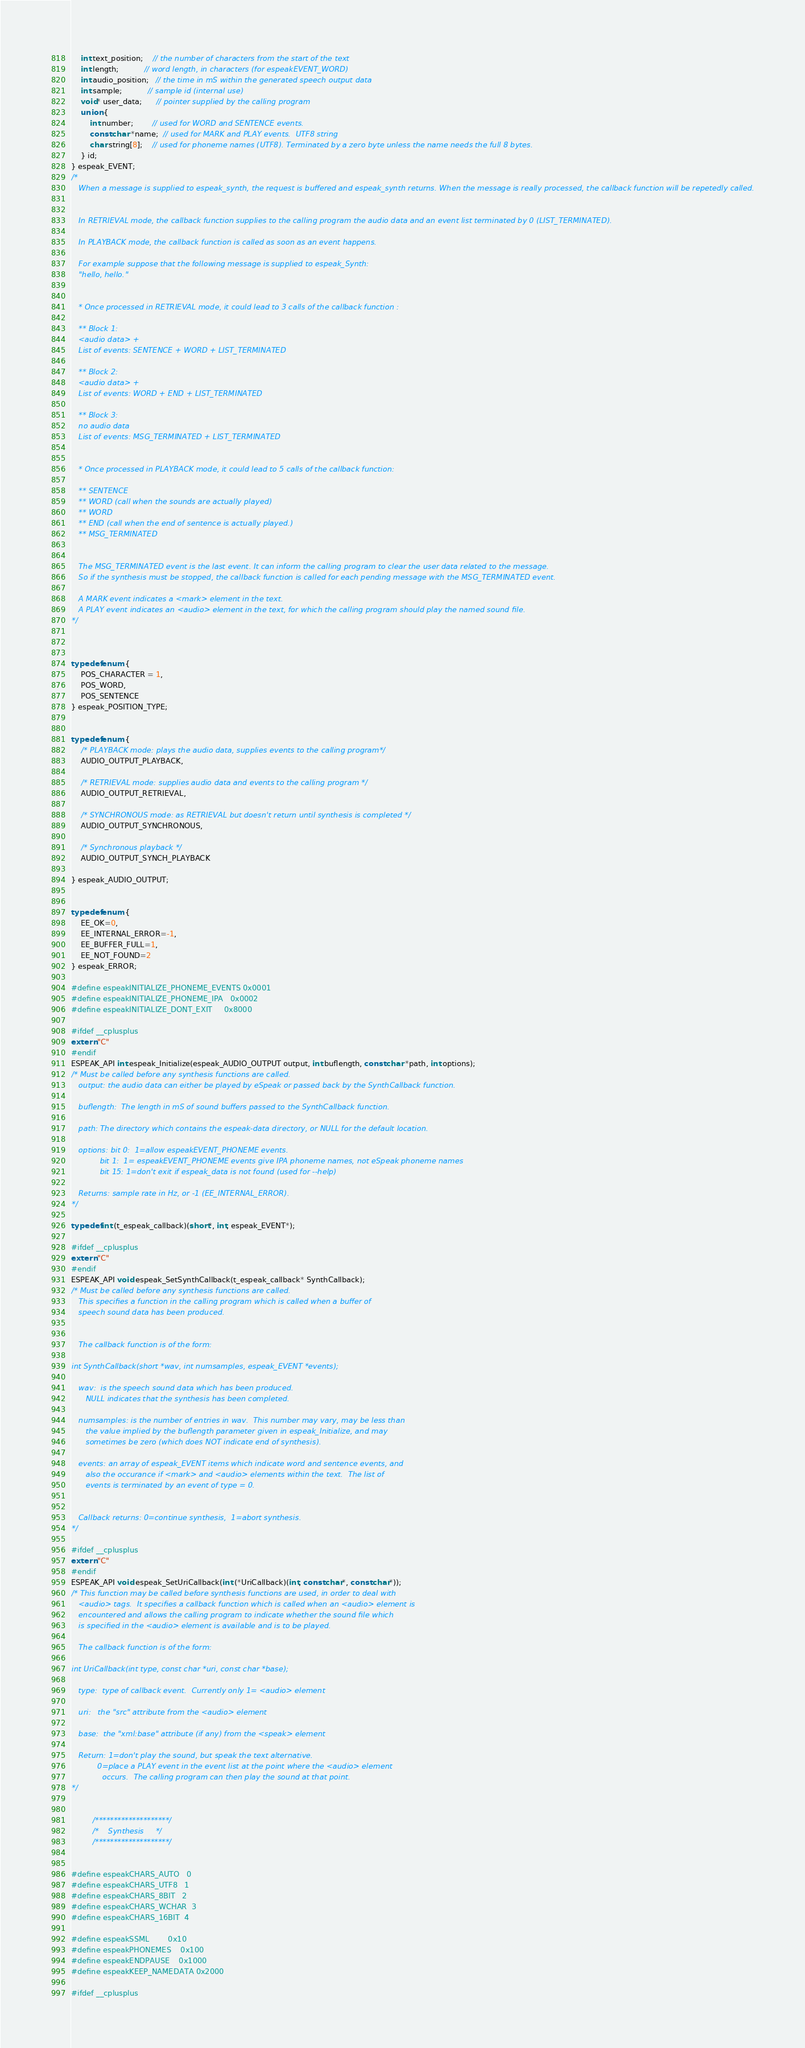Convert code to text. <code><loc_0><loc_0><loc_500><loc_500><_C_>	int text_position;    // the number of characters from the start of the text
	int length;           // word length, in characters (for espeakEVENT_WORD)
	int audio_position;   // the time in mS within the generated speech output data
	int sample;           // sample id (internal use)
	void* user_data;      // pointer supplied by the calling program
	union {
		int number;        // used for WORD and SENTENCE events.
		const char *name;  // used for MARK and PLAY events.  UTF8 string
		char string[8];    // used for phoneme names (UTF8). Terminated by a zero byte unless the name needs the full 8 bytes.
	} id;
} espeak_EVENT;
/* 
   When a message is supplied to espeak_synth, the request is buffered and espeak_synth returns. When the message is really processed, the callback function will be repetedly called.


   In RETRIEVAL mode, the callback function supplies to the calling program the audio data and an event list terminated by 0 (LIST_TERMINATED).

   In PLAYBACK mode, the callback function is called as soon as an event happens.

   For example suppose that the following message is supplied to espeak_Synth: 
   "hello, hello."


   * Once processed in RETRIEVAL mode, it could lead to 3 calls of the callback function :

   ** Block 1:
   <audio data> + 
   List of events: SENTENCE + WORD + LIST_TERMINATED
 
   ** Block 2:
   <audio data> +
   List of events: WORD + END + LIST_TERMINATED

   ** Block 3:
   no audio data
   List of events: MSG_TERMINATED + LIST_TERMINATED


   * Once processed in PLAYBACK mode, it could lead to 5 calls of the callback function:

   ** SENTENCE
   ** WORD (call when the sounds are actually played)
   ** WORD
   ** END (call when the end of sentence is actually played.)
   ** MSG_TERMINATED


   The MSG_TERMINATED event is the last event. It can inform the calling program to clear the user data related to the message.
   So if the synthesis must be stopped, the callback function is called for each pending message with the MSG_TERMINATED event.

   A MARK event indicates a <mark> element in the text.
   A PLAY event indicates an <audio> element in the text, for which the calling program should play the named sound file.
*/



typedef enum {
	POS_CHARACTER = 1,
	POS_WORD,
	POS_SENTENCE
} espeak_POSITION_TYPE;


typedef enum {
	/* PLAYBACK mode: plays the audio data, supplies events to the calling program*/
	AUDIO_OUTPUT_PLAYBACK, 

	/* RETRIEVAL mode: supplies audio data and events to the calling program */
	AUDIO_OUTPUT_RETRIEVAL,
 
	/* SYNCHRONOUS mode: as RETRIEVAL but doesn't return until synthesis is completed */
	AUDIO_OUTPUT_SYNCHRONOUS,

	/* Synchronous playback */
	AUDIO_OUTPUT_SYNCH_PLAYBACK

} espeak_AUDIO_OUTPUT;


typedef enum {
	EE_OK=0,
	EE_INTERNAL_ERROR=-1,
	EE_BUFFER_FULL=1,
	EE_NOT_FOUND=2
} espeak_ERROR;

#define espeakINITIALIZE_PHONEME_EVENTS 0x0001
#define espeakINITIALIZE_PHONEME_IPA   0x0002
#define espeakINITIALIZE_DONT_EXIT     0x8000

#ifdef __cplusplus
extern "C"
#endif
ESPEAK_API int espeak_Initialize(espeak_AUDIO_OUTPUT output, int buflength, const char *path, int options);
/* Must be called before any synthesis functions are called.
   output: the audio data can either be played by eSpeak or passed back by the SynthCallback function.

   buflength:  The length in mS of sound buffers passed to the SynthCallback function.

   path: The directory which contains the espeak-data directory, or NULL for the default location.

   options: bit 0:  1=allow espeakEVENT_PHONEME events.
            bit 1:  1= espeakEVENT_PHONEME events give IPA phoneme names, not eSpeak phoneme names
            bit 15: 1=don't exit if espeak_data is not found (used for --help)

   Returns: sample rate in Hz, or -1 (EE_INTERNAL_ERROR).
*/

typedef int (t_espeak_callback)(short*, int, espeak_EVENT*);

#ifdef __cplusplus
extern "C"
#endif
ESPEAK_API void espeak_SetSynthCallback(t_espeak_callback* SynthCallback);
/* Must be called before any synthesis functions are called.
   This specifies a function in the calling program which is called when a buffer of
   speech sound data has been produced. 


   The callback function is of the form:

int SynthCallback(short *wav, int numsamples, espeak_EVENT *events);

   wav:  is the speech sound data which has been produced.
      NULL indicates that the synthesis has been completed.

   numsamples: is the number of entries in wav.  This number may vary, may be less than
      the value implied by the buflength parameter given in espeak_Initialize, and may
      sometimes be zero (which does NOT indicate end of synthesis).

   events: an array of espeak_EVENT items which indicate word and sentence events, and
      also the occurance if <mark> and <audio> elements within the text.  The list of
      events is terminated by an event of type = 0.


   Callback returns: 0=continue synthesis,  1=abort synthesis.
*/

#ifdef __cplusplus
extern "C"
#endif
ESPEAK_API void espeak_SetUriCallback(int (*UriCallback)(int, const char*, const char*));
/* This function may be called before synthesis functions are used, in order to deal with
   <audio> tags.  It specifies a callback function which is called when an <audio> element is
   encountered and allows the calling program to indicate whether the sound file which
   is specified in the <audio> element is available and is to be played.

   The callback function is of the form:

int UriCallback(int type, const char *uri, const char *base);

   type:  type of callback event.  Currently only 1= <audio> element

   uri:   the "src" attribute from the <audio> element

   base:  the "xml:base" attribute (if any) from the <speak> element

   Return: 1=don't play the sound, but speak the text alternative.
           0=place a PLAY event in the event list at the point where the <audio> element
             occurs.  The calling program can then play the sound at that point.
*/


         /********************/
         /*    Synthesis     */
         /********************/


#define espeakCHARS_AUTO   0
#define espeakCHARS_UTF8   1
#define espeakCHARS_8BIT   2
#define espeakCHARS_WCHAR  3
#define espeakCHARS_16BIT  4

#define espeakSSML        0x10
#define espeakPHONEMES    0x100
#define espeakENDPAUSE    0x1000
#define espeakKEEP_NAMEDATA 0x2000

#ifdef __cplusplus</code> 